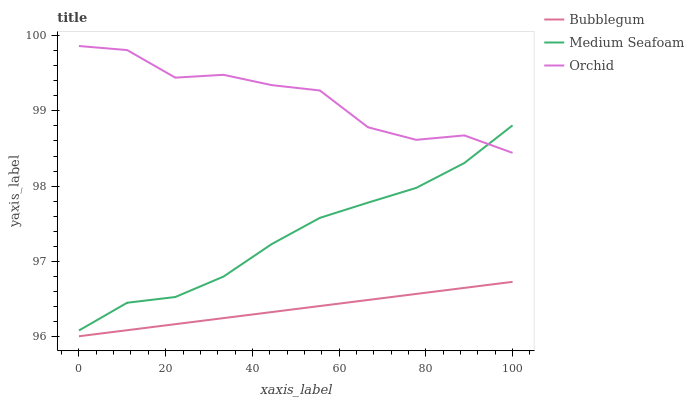Does Bubblegum have the minimum area under the curve?
Answer yes or no. Yes. Does Orchid have the maximum area under the curve?
Answer yes or no. Yes. Does Orchid have the minimum area under the curve?
Answer yes or no. No. Does Bubblegum have the maximum area under the curve?
Answer yes or no. No. Is Bubblegum the smoothest?
Answer yes or no. Yes. Is Orchid the roughest?
Answer yes or no. Yes. Is Orchid the smoothest?
Answer yes or no. No. Is Bubblegum the roughest?
Answer yes or no. No. Does Orchid have the lowest value?
Answer yes or no. No. Does Orchid have the highest value?
Answer yes or no. Yes. Does Bubblegum have the highest value?
Answer yes or no. No. Is Bubblegum less than Orchid?
Answer yes or no. Yes. Is Orchid greater than Bubblegum?
Answer yes or no. Yes. Does Medium Seafoam intersect Orchid?
Answer yes or no. Yes. Is Medium Seafoam less than Orchid?
Answer yes or no. No. Is Medium Seafoam greater than Orchid?
Answer yes or no. No. Does Bubblegum intersect Orchid?
Answer yes or no. No. 